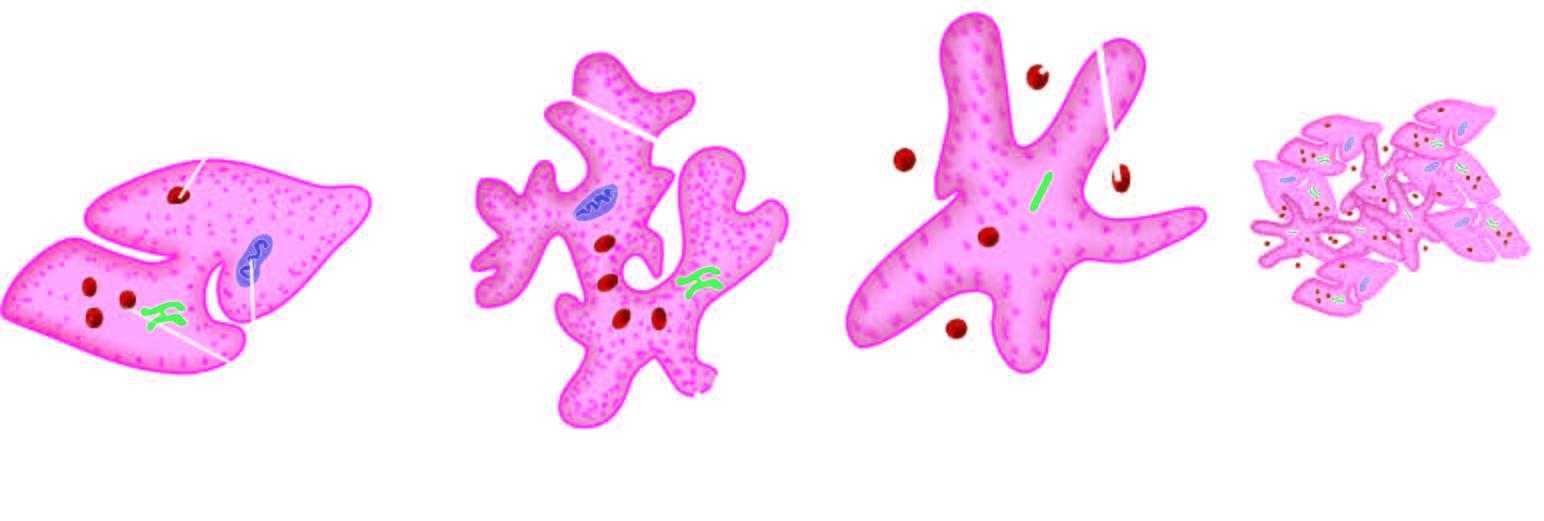what is dispersed in the cell?
Answer the question using a single word or phrase. Normal non-activated platelet 